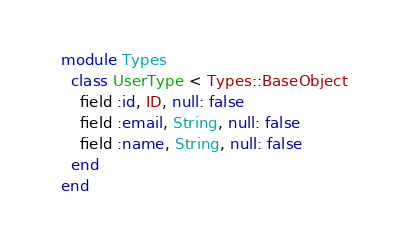<code> <loc_0><loc_0><loc_500><loc_500><_Ruby_>module Types
  class UserType < Types::BaseObject
    field :id, ID, null: false
    field :email, String, null: false
    field :name, String, null: false
  end
end
</code> 